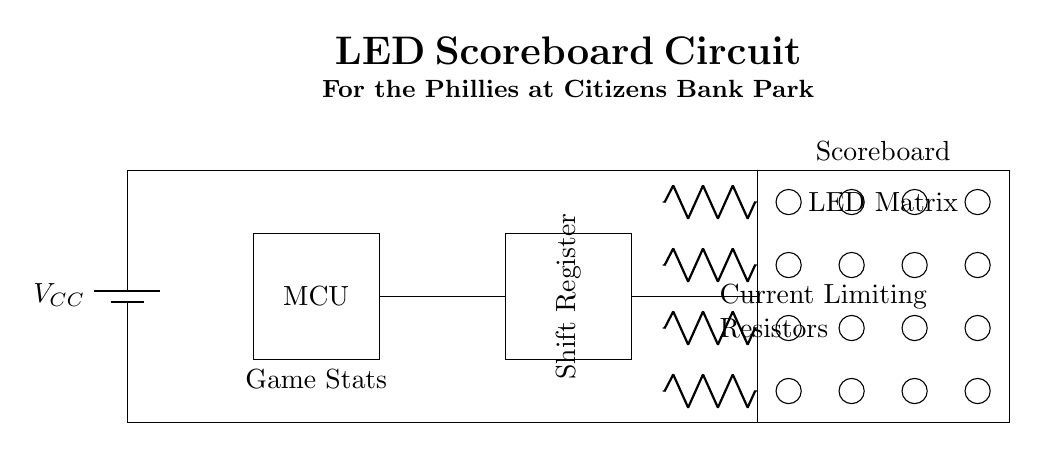What component is used to control the display? The microcontroller is the component controlling the LED matrix, as it interfaces directly with the shift register to send data to the scoreboard.
Answer: Microcontroller What does the shift register do in this circuit? The shift register is used to convert parallel data from the microcontroller into serial data to control the LED matrix, allowing efficient data transfer for displaying game statistics.
Answer: Converts data What is the purpose of the current limiting resistors? The current limiting resistors are placed in series to prevent excessive current from damaging the LEDs in the matrix, ensuring they operate safely and efficiently.
Answer: Prevent excessive current How many LEDs are shown in the matrix? The matrix has sixteen individual LEDs, arranged in a grid of four rows and four columns. Each LED is represented by a small circle in the diagram.
Answer: Sixteen What is the voltage source connected to the circuit? The voltage source is labeled as V sub CC, which provides power to the entire circuit including the microcontroller and LED matrix.
Answer: V sub CC How does the microcontroller communicate with the shift register? The microcontroller outputs data to the shift register, which then serializes the information to control the LEDs, establishing a communication link for updating the display.
Answer: Outputs data What theme is referenced in the title of the circuit diagram? The title of the circuit references the Philadelphia Phillies, highlighting its use for scoring during baseball games at Citizens Bank Park.
Answer: Philadelphia Phillies 